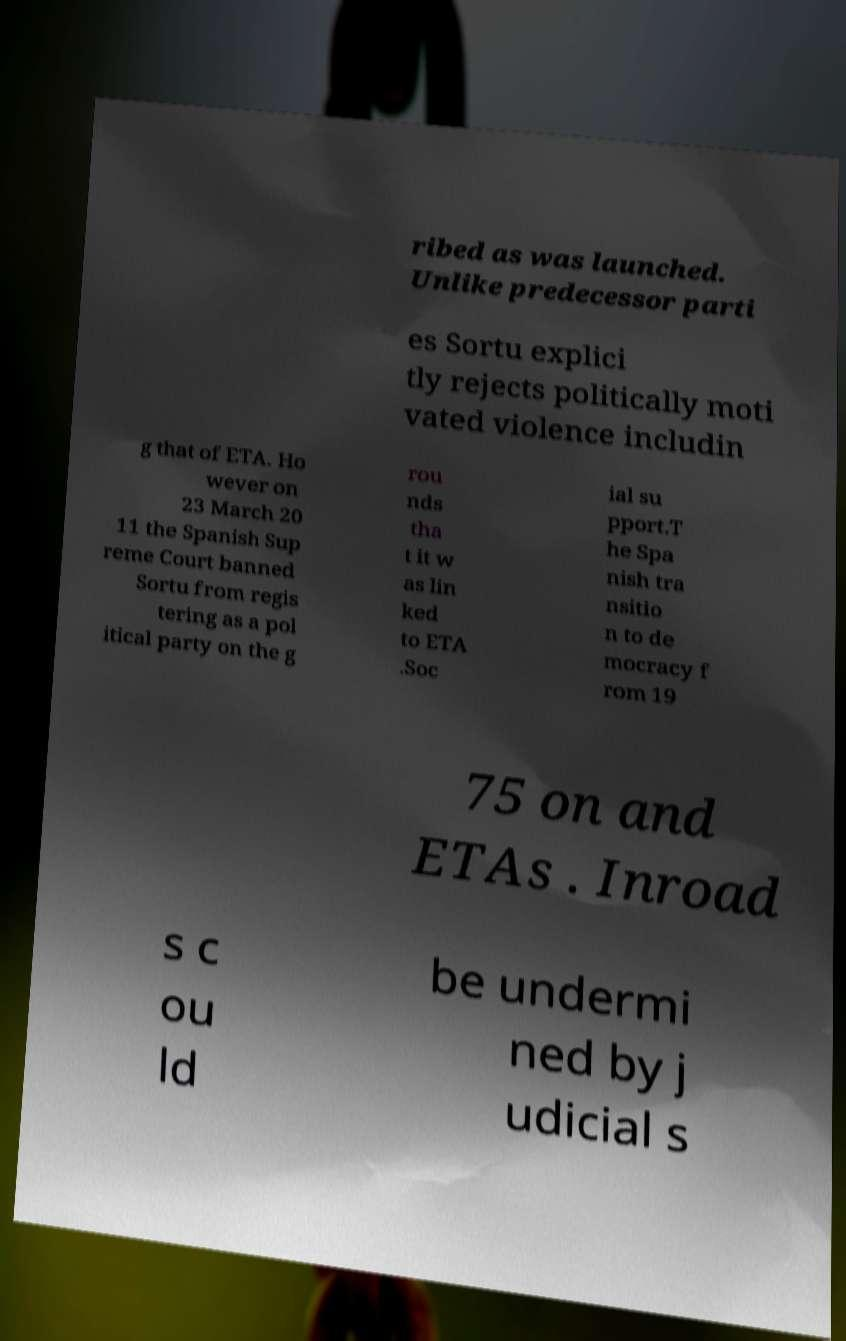Could you assist in decoding the text presented in this image and type it out clearly? ribed as was launched. Unlike predecessor parti es Sortu explici tly rejects politically moti vated violence includin g that of ETA. Ho wever on 23 March 20 11 the Spanish Sup reme Court banned Sortu from regis tering as a pol itical party on the g rou nds tha t it w as lin ked to ETA .Soc ial su pport.T he Spa nish tra nsitio n to de mocracy f rom 19 75 on and ETAs . Inroad s c ou ld be undermi ned by j udicial s 